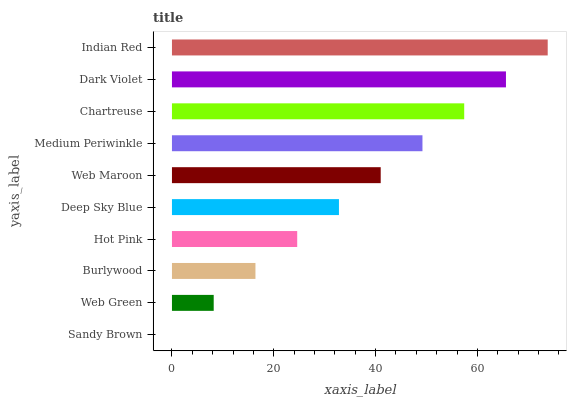Is Sandy Brown the minimum?
Answer yes or no. Yes. Is Indian Red the maximum?
Answer yes or no. Yes. Is Web Green the minimum?
Answer yes or no. No. Is Web Green the maximum?
Answer yes or no. No. Is Web Green greater than Sandy Brown?
Answer yes or no. Yes. Is Sandy Brown less than Web Green?
Answer yes or no. Yes. Is Sandy Brown greater than Web Green?
Answer yes or no. No. Is Web Green less than Sandy Brown?
Answer yes or no. No. Is Web Maroon the high median?
Answer yes or no. Yes. Is Deep Sky Blue the low median?
Answer yes or no. Yes. Is Dark Violet the high median?
Answer yes or no. No. Is Burlywood the low median?
Answer yes or no. No. 